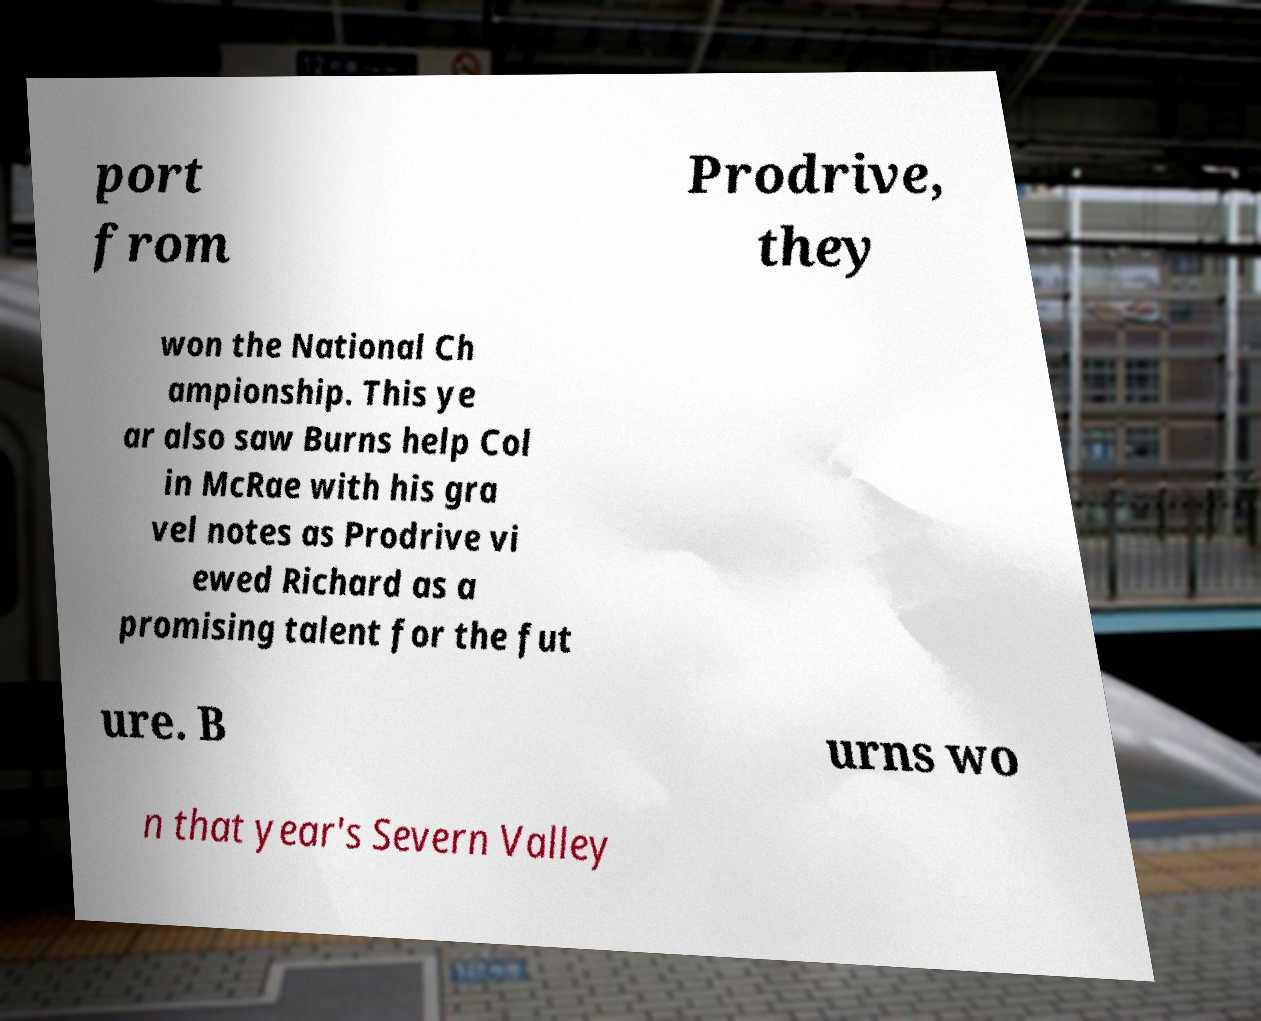For documentation purposes, I need the text within this image transcribed. Could you provide that? port from Prodrive, they won the National Ch ampionship. This ye ar also saw Burns help Col in McRae with his gra vel notes as Prodrive vi ewed Richard as a promising talent for the fut ure. B urns wo n that year's Severn Valley 